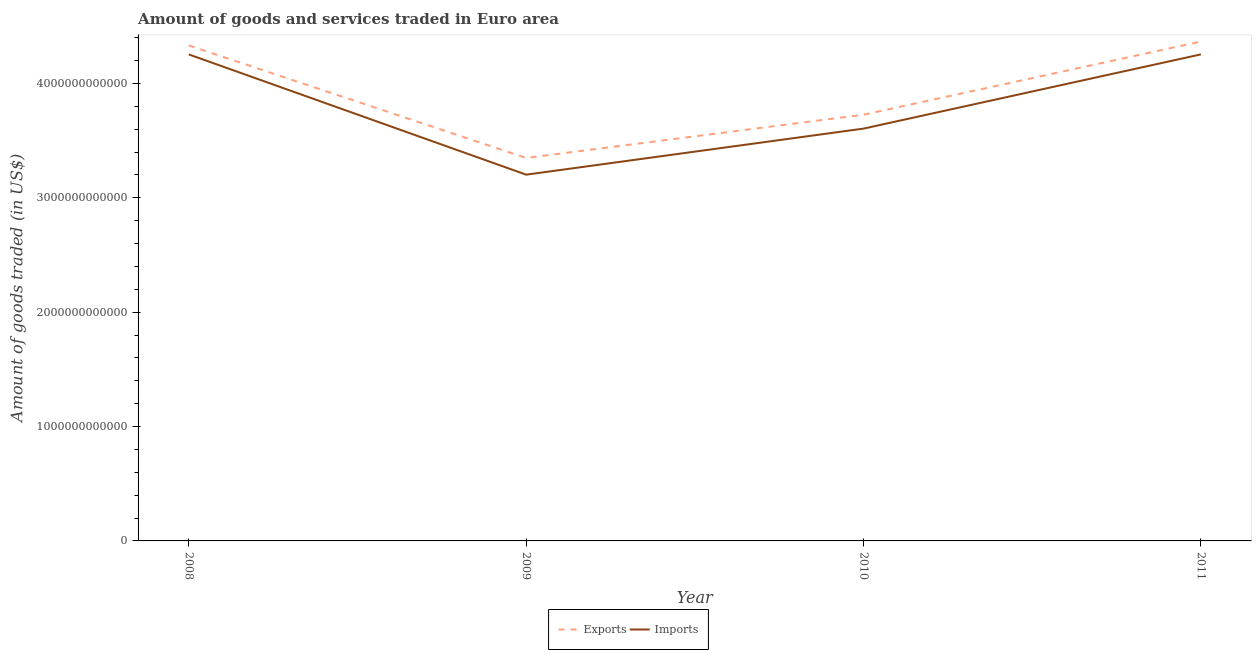How many different coloured lines are there?
Keep it short and to the point. 2. Does the line corresponding to amount of goods imported intersect with the line corresponding to amount of goods exported?
Make the answer very short. No. What is the amount of goods exported in 2010?
Your answer should be compact. 3.73e+12. Across all years, what is the maximum amount of goods imported?
Provide a succinct answer. 4.25e+12. Across all years, what is the minimum amount of goods imported?
Offer a terse response. 3.20e+12. In which year was the amount of goods exported minimum?
Ensure brevity in your answer.  2009. What is the total amount of goods imported in the graph?
Offer a terse response. 1.53e+13. What is the difference between the amount of goods imported in 2008 and that in 2010?
Provide a succinct answer. 6.48e+11. What is the difference between the amount of goods imported in 2010 and the amount of goods exported in 2008?
Your answer should be very brief. -7.27e+11. What is the average amount of goods imported per year?
Give a very brief answer. 3.83e+12. In the year 2011, what is the difference between the amount of goods exported and amount of goods imported?
Make the answer very short. 1.12e+11. In how many years, is the amount of goods exported greater than 3400000000000 US$?
Offer a terse response. 3. What is the ratio of the amount of goods imported in 2008 to that in 2011?
Ensure brevity in your answer.  1. Is the difference between the amount of goods exported in 2010 and 2011 greater than the difference between the amount of goods imported in 2010 and 2011?
Provide a succinct answer. Yes. What is the difference between the highest and the second highest amount of goods exported?
Provide a succinct answer. 3.43e+1. What is the difference between the highest and the lowest amount of goods exported?
Your answer should be very brief. 1.02e+12. Does the amount of goods imported monotonically increase over the years?
Offer a very short reply. No. Is the amount of goods exported strictly less than the amount of goods imported over the years?
Offer a very short reply. No. How many lines are there?
Make the answer very short. 2. What is the difference between two consecutive major ticks on the Y-axis?
Offer a terse response. 1.00e+12. Does the graph contain any zero values?
Provide a succinct answer. No. Where does the legend appear in the graph?
Offer a very short reply. Bottom center. How are the legend labels stacked?
Offer a terse response. Horizontal. What is the title of the graph?
Your answer should be compact. Amount of goods and services traded in Euro area. What is the label or title of the X-axis?
Your answer should be compact. Year. What is the label or title of the Y-axis?
Ensure brevity in your answer.  Amount of goods traded (in US$). What is the Amount of goods traded (in US$) in Exports in 2008?
Provide a short and direct response. 4.33e+12. What is the Amount of goods traded (in US$) of Imports in 2008?
Provide a short and direct response. 4.25e+12. What is the Amount of goods traded (in US$) in Exports in 2009?
Ensure brevity in your answer.  3.35e+12. What is the Amount of goods traded (in US$) in Imports in 2009?
Give a very brief answer. 3.20e+12. What is the Amount of goods traded (in US$) in Exports in 2010?
Offer a very short reply. 3.73e+12. What is the Amount of goods traded (in US$) in Imports in 2010?
Keep it short and to the point. 3.60e+12. What is the Amount of goods traded (in US$) of Exports in 2011?
Your response must be concise. 4.37e+12. What is the Amount of goods traded (in US$) in Imports in 2011?
Give a very brief answer. 4.25e+12. Across all years, what is the maximum Amount of goods traded (in US$) of Exports?
Your answer should be compact. 4.37e+12. Across all years, what is the maximum Amount of goods traded (in US$) in Imports?
Give a very brief answer. 4.25e+12. Across all years, what is the minimum Amount of goods traded (in US$) of Exports?
Ensure brevity in your answer.  3.35e+12. Across all years, what is the minimum Amount of goods traded (in US$) of Imports?
Provide a short and direct response. 3.20e+12. What is the total Amount of goods traded (in US$) of Exports in the graph?
Provide a succinct answer. 1.58e+13. What is the total Amount of goods traded (in US$) of Imports in the graph?
Your answer should be compact. 1.53e+13. What is the difference between the Amount of goods traded (in US$) of Exports in 2008 and that in 2009?
Your answer should be very brief. 9.84e+11. What is the difference between the Amount of goods traded (in US$) in Imports in 2008 and that in 2009?
Ensure brevity in your answer.  1.05e+12. What is the difference between the Amount of goods traded (in US$) of Exports in 2008 and that in 2010?
Your response must be concise. 6.05e+11. What is the difference between the Amount of goods traded (in US$) in Imports in 2008 and that in 2010?
Offer a very short reply. 6.48e+11. What is the difference between the Amount of goods traded (in US$) of Exports in 2008 and that in 2011?
Provide a succinct answer. -3.43e+1. What is the difference between the Amount of goods traded (in US$) of Imports in 2008 and that in 2011?
Your answer should be compact. -4.04e+08. What is the difference between the Amount of goods traded (in US$) of Exports in 2009 and that in 2010?
Ensure brevity in your answer.  -3.78e+11. What is the difference between the Amount of goods traded (in US$) in Imports in 2009 and that in 2010?
Your response must be concise. -4.03e+11. What is the difference between the Amount of goods traded (in US$) of Exports in 2009 and that in 2011?
Your answer should be compact. -1.02e+12. What is the difference between the Amount of goods traded (in US$) in Imports in 2009 and that in 2011?
Make the answer very short. -1.05e+12. What is the difference between the Amount of goods traded (in US$) of Exports in 2010 and that in 2011?
Provide a short and direct response. -6.40e+11. What is the difference between the Amount of goods traded (in US$) of Imports in 2010 and that in 2011?
Your answer should be compact. -6.49e+11. What is the difference between the Amount of goods traded (in US$) of Exports in 2008 and the Amount of goods traded (in US$) of Imports in 2009?
Provide a succinct answer. 1.13e+12. What is the difference between the Amount of goods traded (in US$) in Exports in 2008 and the Amount of goods traded (in US$) in Imports in 2010?
Provide a succinct answer. 7.27e+11. What is the difference between the Amount of goods traded (in US$) in Exports in 2008 and the Amount of goods traded (in US$) in Imports in 2011?
Provide a short and direct response. 7.81e+1. What is the difference between the Amount of goods traded (in US$) in Exports in 2009 and the Amount of goods traded (in US$) in Imports in 2010?
Make the answer very short. -2.57e+11. What is the difference between the Amount of goods traded (in US$) of Exports in 2009 and the Amount of goods traded (in US$) of Imports in 2011?
Offer a terse response. -9.06e+11. What is the difference between the Amount of goods traded (in US$) of Exports in 2010 and the Amount of goods traded (in US$) of Imports in 2011?
Offer a terse response. -5.27e+11. What is the average Amount of goods traded (in US$) in Exports per year?
Provide a succinct answer. 3.94e+12. What is the average Amount of goods traded (in US$) of Imports per year?
Your answer should be compact. 3.83e+12. In the year 2008, what is the difference between the Amount of goods traded (in US$) in Exports and Amount of goods traded (in US$) in Imports?
Ensure brevity in your answer.  7.85e+1. In the year 2009, what is the difference between the Amount of goods traded (in US$) in Exports and Amount of goods traded (in US$) in Imports?
Your answer should be compact. 1.46e+11. In the year 2010, what is the difference between the Amount of goods traded (in US$) in Exports and Amount of goods traded (in US$) in Imports?
Offer a very short reply. 1.22e+11. In the year 2011, what is the difference between the Amount of goods traded (in US$) in Exports and Amount of goods traded (in US$) in Imports?
Your response must be concise. 1.12e+11. What is the ratio of the Amount of goods traded (in US$) of Exports in 2008 to that in 2009?
Ensure brevity in your answer.  1.29. What is the ratio of the Amount of goods traded (in US$) of Imports in 2008 to that in 2009?
Your answer should be compact. 1.33. What is the ratio of the Amount of goods traded (in US$) of Exports in 2008 to that in 2010?
Make the answer very short. 1.16. What is the ratio of the Amount of goods traded (in US$) in Imports in 2008 to that in 2010?
Your answer should be compact. 1.18. What is the ratio of the Amount of goods traded (in US$) in Exports in 2008 to that in 2011?
Your response must be concise. 0.99. What is the ratio of the Amount of goods traded (in US$) of Imports in 2008 to that in 2011?
Your response must be concise. 1. What is the ratio of the Amount of goods traded (in US$) of Exports in 2009 to that in 2010?
Your response must be concise. 0.9. What is the ratio of the Amount of goods traded (in US$) in Imports in 2009 to that in 2010?
Your answer should be compact. 0.89. What is the ratio of the Amount of goods traded (in US$) of Exports in 2009 to that in 2011?
Give a very brief answer. 0.77. What is the ratio of the Amount of goods traded (in US$) of Imports in 2009 to that in 2011?
Keep it short and to the point. 0.75. What is the ratio of the Amount of goods traded (in US$) of Exports in 2010 to that in 2011?
Make the answer very short. 0.85. What is the ratio of the Amount of goods traded (in US$) of Imports in 2010 to that in 2011?
Provide a short and direct response. 0.85. What is the difference between the highest and the second highest Amount of goods traded (in US$) in Exports?
Keep it short and to the point. 3.43e+1. What is the difference between the highest and the second highest Amount of goods traded (in US$) of Imports?
Give a very brief answer. 4.04e+08. What is the difference between the highest and the lowest Amount of goods traded (in US$) of Exports?
Offer a terse response. 1.02e+12. What is the difference between the highest and the lowest Amount of goods traded (in US$) of Imports?
Offer a terse response. 1.05e+12. 